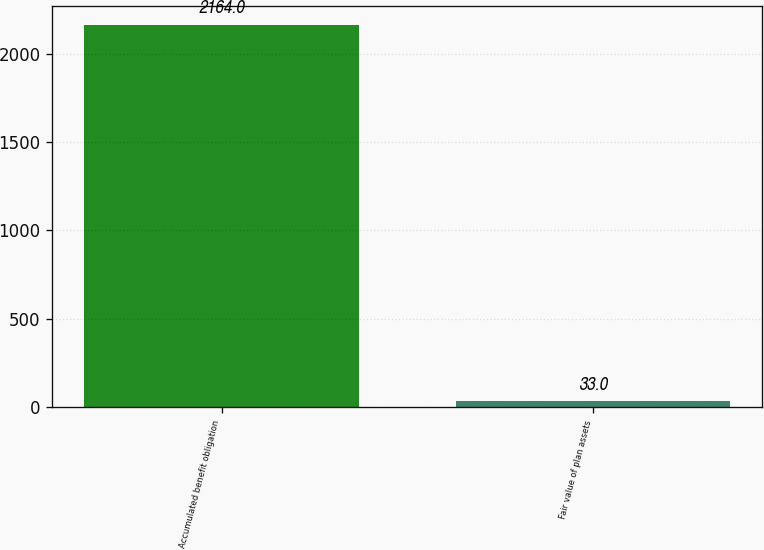Convert chart to OTSL. <chart><loc_0><loc_0><loc_500><loc_500><bar_chart><fcel>Accumulated benefit obligation<fcel>Fair value of plan assets<nl><fcel>2164<fcel>33<nl></chart> 